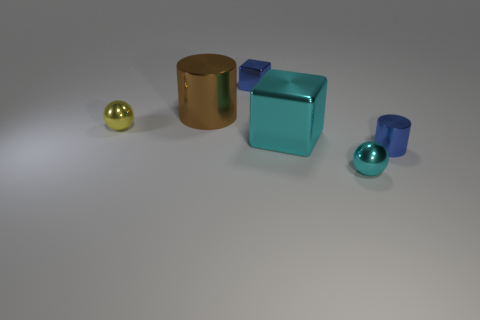What is the shape of the small thing that is behind the shiny cylinder on the left side of the ball that is in front of the small blue cylinder?
Your response must be concise. Cube. There is a large object that is in front of the small yellow ball; does it have the same color as the big cylinder in front of the blue block?
Keep it short and to the point. No. What number of large cyan cubes are there?
Your response must be concise. 1. Are there any large brown cylinders behind the cyan metal block?
Ensure brevity in your answer.  Yes. Is the tiny sphere in front of the small shiny cylinder made of the same material as the cube to the left of the large cyan metal thing?
Your answer should be very brief. Yes. Are there fewer small metal cubes that are right of the blue shiny cylinder than small cyan balls?
Give a very brief answer. Yes. There is a small metallic block that is right of the tiny yellow shiny sphere; what is its color?
Make the answer very short. Blue. What material is the ball to the left of the tiny shiny object that is behind the big brown cylinder?
Make the answer very short. Metal. Is there a cyan metal ball of the same size as the blue metal cylinder?
Offer a terse response. Yes. What number of things are either tiny spheres that are to the left of the brown metallic cylinder or tiny blue shiny things behind the large cylinder?
Offer a very short reply. 2. 